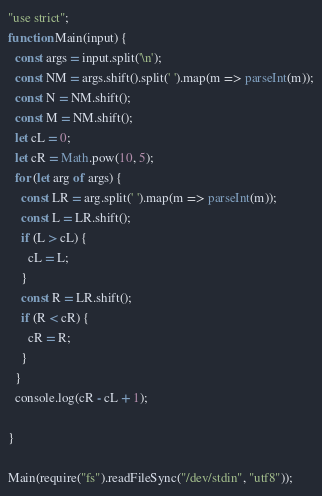<code> <loc_0><loc_0><loc_500><loc_500><_JavaScript_>"use strict";
function Main(input) {
  const args = input.split('\n');
  const NM = args.shift().split(' ').map(m => parseInt(m));
  const N = NM.shift();
  const M = NM.shift();
  let cL = 0;
  let cR = Math.pow(10, 5);
  for (let arg of args) {
    const LR = arg.split(' ').map(m => parseInt(m));
    const L = LR.shift();
    if (L > cL) {
      cL = L;
    }
    const R = LR.shift();
    if (R < cR) {
      cR = R;
    }
  }
  console.log(cR - cL + 1);

}

Main(require("fs").readFileSync("/dev/stdin", "utf8"));
</code> 